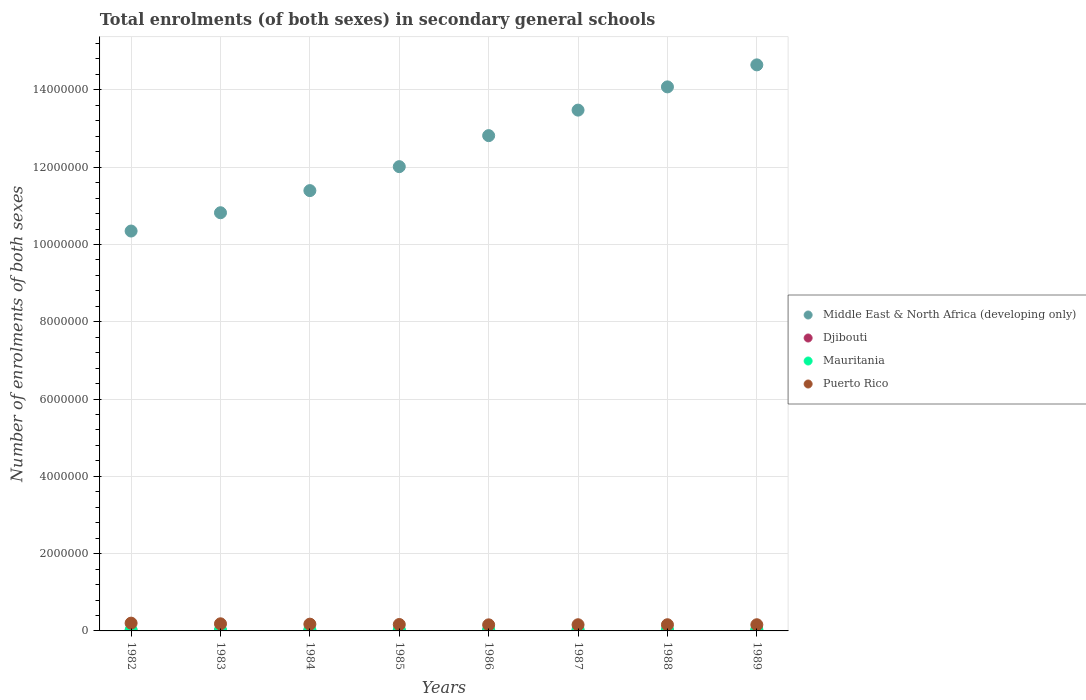What is the number of enrolments in secondary schools in Middle East & North Africa (developing only) in 1988?
Ensure brevity in your answer.  1.41e+07. Across all years, what is the maximum number of enrolments in secondary schools in Puerto Rico?
Ensure brevity in your answer.  2.01e+05. Across all years, what is the minimum number of enrolments in secondary schools in Djibouti?
Your response must be concise. 4076. In which year was the number of enrolments in secondary schools in Middle East & North Africa (developing only) minimum?
Offer a very short reply. 1982. What is the total number of enrolments in secondary schools in Middle East & North Africa (developing only) in the graph?
Offer a very short reply. 9.96e+07. What is the difference between the number of enrolments in secondary schools in Middle East & North Africa (developing only) in 1983 and that in 1984?
Provide a succinct answer. -5.73e+05. What is the difference between the number of enrolments in secondary schools in Puerto Rico in 1983 and the number of enrolments in secondary schools in Middle East & North Africa (developing only) in 1986?
Give a very brief answer. -1.26e+07. What is the average number of enrolments in secondary schools in Mauritania per year?
Make the answer very short. 3.13e+04. In the year 1983, what is the difference between the number of enrolments in secondary schools in Djibouti and number of enrolments in secondary schools in Middle East & North Africa (developing only)?
Your response must be concise. -1.08e+07. What is the ratio of the number of enrolments in secondary schools in Middle East & North Africa (developing only) in 1985 to that in 1988?
Offer a terse response. 0.85. Is the number of enrolments in secondary schools in Mauritania in 1986 less than that in 1989?
Keep it short and to the point. Yes. What is the difference between the highest and the second highest number of enrolments in secondary schools in Middle East & North Africa (developing only)?
Provide a short and direct response. 5.70e+05. What is the difference between the highest and the lowest number of enrolments in secondary schools in Puerto Rico?
Give a very brief answer. 4.36e+04. In how many years, is the number of enrolments in secondary schools in Djibouti greater than the average number of enrolments in secondary schools in Djibouti taken over all years?
Keep it short and to the point. 3. Is it the case that in every year, the sum of the number of enrolments in secondary schools in Puerto Rico and number of enrolments in secondary schools in Middle East & North Africa (developing only)  is greater than the sum of number of enrolments in secondary schools in Djibouti and number of enrolments in secondary schools in Mauritania?
Your response must be concise. No. Is it the case that in every year, the sum of the number of enrolments in secondary schools in Puerto Rico and number of enrolments in secondary schools in Mauritania  is greater than the number of enrolments in secondary schools in Middle East & North Africa (developing only)?
Provide a short and direct response. No. Does the number of enrolments in secondary schools in Middle East & North Africa (developing only) monotonically increase over the years?
Offer a terse response. Yes. Is the number of enrolments in secondary schools in Mauritania strictly less than the number of enrolments in secondary schools in Middle East & North Africa (developing only) over the years?
Provide a succinct answer. Yes. How many dotlines are there?
Your response must be concise. 4. How many years are there in the graph?
Make the answer very short. 8. Are the values on the major ticks of Y-axis written in scientific E-notation?
Offer a very short reply. No. Where does the legend appear in the graph?
Keep it short and to the point. Center right. How many legend labels are there?
Your answer should be very brief. 4. How are the legend labels stacked?
Offer a very short reply. Vertical. What is the title of the graph?
Give a very brief answer. Total enrolments (of both sexes) in secondary general schools. What is the label or title of the X-axis?
Make the answer very short. Years. What is the label or title of the Y-axis?
Your answer should be compact. Number of enrolments of both sexes. What is the Number of enrolments of both sexes in Middle East & North Africa (developing only) in 1982?
Your answer should be very brief. 1.03e+07. What is the Number of enrolments of both sexes in Djibouti in 1982?
Ensure brevity in your answer.  4076. What is the Number of enrolments of both sexes in Mauritania in 1982?
Provide a succinct answer. 2.28e+04. What is the Number of enrolments of both sexes in Puerto Rico in 1982?
Your response must be concise. 2.01e+05. What is the Number of enrolments of both sexes in Middle East & North Africa (developing only) in 1983?
Your answer should be very brief. 1.08e+07. What is the Number of enrolments of both sexes of Djibouti in 1983?
Ensure brevity in your answer.  4429. What is the Number of enrolments of both sexes of Mauritania in 1983?
Make the answer very short. 2.57e+04. What is the Number of enrolments of both sexes in Puerto Rico in 1983?
Give a very brief answer. 1.84e+05. What is the Number of enrolments of both sexes in Middle East & North Africa (developing only) in 1984?
Ensure brevity in your answer.  1.14e+07. What is the Number of enrolments of both sexes of Djibouti in 1984?
Make the answer very short. 4791. What is the Number of enrolments of both sexes of Mauritania in 1984?
Give a very brief answer. 2.79e+04. What is the Number of enrolments of both sexes in Puerto Rico in 1984?
Provide a short and direct response. 1.75e+05. What is the Number of enrolments of both sexes of Middle East & North Africa (developing only) in 1985?
Ensure brevity in your answer.  1.20e+07. What is the Number of enrolments of both sexes in Djibouti in 1985?
Your response must be concise. 4978. What is the Number of enrolments of both sexes of Mauritania in 1985?
Give a very brief answer. 3.08e+04. What is the Number of enrolments of both sexes of Puerto Rico in 1985?
Ensure brevity in your answer.  1.66e+05. What is the Number of enrolments of both sexes in Middle East & North Africa (developing only) in 1986?
Provide a short and direct response. 1.28e+07. What is the Number of enrolments of both sexes of Djibouti in 1986?
Keep it short and to the point. 5057. What is the Number of enrolments of both sexes of Mauritania in 1986?
Your response must be concise. 3.31e+04. What is the Number of enrolments of both sexes in Puerto Rico in 1986?
Keep it short and to the point. 1.57e+05. What is the Number of enrolments of both sexes of Middle East & North Africa (developing only) in 1987?
Offer a very short reply. 1.35e+07. What is the Number of enrolments of both sexes of Djibouti in 1987?
Your response must be concise. 5537. What is the Number of enrolments of both sexes in Mauritania in 1987?
Your answer should be compact. 3.51e+04. What is the Number of enrolments of both sexes of Middle East & North Africa (developing only) in 1988?
Give a very brief answer. 1.41e+07. What is the Number of enrolments of both sexes in Djibouti in 1988?
Offer a very short reply. 5799. What is the Number of enrolments of both sexes of Mauritania in 1988?
Your answer should be very brief. 3.74e+04. What is the Number of enrolments of both sexes of Puerto Rico in 1988?
Keep it short and to the point. 1.60e+05. What is the Number of enrolments of both sexes of Middle East & North Africa (developing only) in 1989?
Offer a terse response. 1.46e+07. What is the Number of enrolments of both sexes of Djibouti in 1989?
Make the answer very short. 6536. What is the Number of enrolments of both sexes of Mauritania in 1989?
Make the answer very short. 3.74e+04. What is the Number of enrolments of both sexes of Puerto Rico in 1989?
Provide a succinct answer. 1.60e+05. Across all years, what is the maximum Number of enrolments of both sexes of Middle East & North Africa (developing only)?
Your answer should be very brief. 1.46e+07. Across all years, what is the maximum Number of enrolments of both sexes of Djibouti?
Offer a terse response. 6536. Across all years, what is the maximum Number of enrolments of both sexes in Mauritania?
Ensure brevity in your answer.  3.74e+04. Across all years, what is the maximum Number of enrolments of both sexes of Puerto Rico?
Provide a succinct answer. 2.01e+05. Across all years, what is the minimum Number of enrolments of both sexes of Middle East & North Africa (developing only)?
Give a very brief answer. 1.03e+07. Across all years, what is the minimum Number of enrolments of both sexes of Djibouti?
Ensure brevity in your answer.  4076. Across all years, what is the minimum Number of enrolments of both sexes in Mauritania?
Your response must be concise. 2.28e+04. Across all years, what is the minimum Number of enrolments of both sexes of Puerto Rico?
Your response must be concise. 1.57e+05. What is the total Number of enrolments of both sexes in Middle East & North Africa (developing only) in the graph?
Make the answer very short. 9.96e+07. What is the total Number of enrolments of both sexes in Djibouti in the graph?
Your response must be concise. 4.12e+04. What is the total Number of enrolments of both sexes of Mauritania in the graph?
Make the answer very short. 2.50e+05. What is the total Number of enrolments of both sexes of Puerto Rico in the graph?
Provide a short and direct response. 1.36e+06. What is the difference between the Number of enrolments of both sexes in Middle East & North Africa (developing only) in 1982 and that in 1983?
Your answer should be very brief. -4.73e+05. What is the difference between the Number of enrolments of both sexes of Djibouti in 1982 and that in 1983?
Ensure brevity in your answer.  -353. What is the difference between the Number of enrolments of both sexes in Mauritania in 1982 and that in 1983?
Ensure brevity in your answer.  -2866. What is the difference between the Number of enrolments of both sexes of Puerto Rico in 1982 and that in 1983?
Give a very brief answer. 1.69e+04. What is the difference between the Number of enrolments of both sexes of Middle East & North Africa (developing only) in 1982 and that in 1984?
Ensure brevity in your answer.  -1.05e+06. What is the difference between the Number of enrolments of both sexes in Djibouti in 1982 and that in 1984?
Offer a terse response. -715. What is the difference between the Number of enrolments of both sexes of Mauritania in 1982 and that in 1984?
Your answer should be very brief. -5090. What is the difference between the Number of enrolments of both sexes in Puerto Rico in 1982 and that in 1984?
Your response must be concise. 2.59e+04. What is the difference between the Number of enrolments of both sexes of Middle East & North Africa (developing only) in 1982 and that in 1985?
Offer a very short reply. -1.67e+06. What is the difference between the Number of enrolments of both sexes of Djibouti in 1982 and that in 1985?
Offer a very short reply. -902. What is the difference between the Number of enrolments of both sexes in Mauritania in 1982 and that in 1985?
Ensure brevity in your answer.  -8006. What is the difference between the Number of enrolments of both sexes of Puerto Rico in 1982 and that in 1985?
Your response must be concise. 3.50e+04. What is the difference between the Number of enrolments of both sexes in Middle East & North Africa (developing only) in 1982 and that in 1986?
Keep it short and to the point. -2.47e+06. What is the difference between the Number of enrolments of both sexes in Djibouti in 1982 and that in 1986?
Your answer should be very brief. -981. What is the difference between the Number of enrolments of both sexes in Mauritania in 1982 and that in 1986?
Your answer should be very brief. -1.03e+04. What is the difference between the Number of enrolments of both sexes of Puerto Rico in 1982 and that in 1986?
Your answer should be very brief. 4.36e+04. What is the difference between the Number of enrolments of both sexes in Middle East & North Africa (developing only) in 1982 and that in 1987?
Provide a short and direct response. -3.13e+06. What is the difference between the Number of enrolments of both sexes of Djibouti in 1982 and that in 1987?
Your answer should be compact. -1461. What is the difference between the Number of enrolments of both sexes in Mauritania in 1982 and that in 1987?
Provide a short and direct response. -1.23e+04. What is the difference between the Number of enrolments of both sexes in Puerto Rico in 1982 and that in 1987?
Offer a terse response. 4.10e+04. What is the difference between the Number of enrolments of both sexes of Middle East & North Africa (developing only) in 1982 and that in 1988?
Keep it short and to the point. -3.73e+06. What is the difference between the Number of enrolments of both sexes of Djibouti in 1982 and that in 1988?
Keep it short and to the point. -1723. What is the difference between the Number of enrolments of both sexes of Mauritania in 1982 and that in 1988?
Keep it short and to the point. -1.46e+04. What is the difference between the Number of enrolments of both sexes in Puerto Rico in 1982 and that in 1988?
Your answer should be compact. 4.10e+04. What is the difference between the Number of enrolments of both sexes of Middle East & North Africa (developing only) in 1982 and that in 1989?
Provide a succinct answer. -4.30e+06. What is the difference between the Number of enrolments of both sexes of Djibouti in 1982 and that in 1989?
Offer a terse response. -2460. What is the difference between the Number of enrolments of both sexes of Mauritania in 1982 and that in 1989?
Your answer should be compact. -1.45e+04. What is the difference between the Number of enrolments of both sexes of Puerto Rico in 1982 and that in 1989?
Give a very brief answer. 4.10e+04. What is the difference between the Number of enrolments of both sexes in Middle East & North Africa (developing only) in 1983 and that in 1984?
Your answer should be compact. -5.73e+05. What is the difference between the Number of enrolments of both sexes of Djibouti in 1983 and that in 1984?
Give a very brief answer. -362. What is the difference between the Number of enrolments of both sexes of Mauritania in 1983 and that in 1984?
Offer a terse response. -2224. What is the difference between the Number of enrolments of both sexes of Puerto Rico in 1983 and that in 1984?
Provide a succinct answer. 9004. What is the difference between the Number of enrolments of both sexes of Middle East & North Africa (developing only) in 1983 and that in 1985?
Provide a succinct answer. -1.19e+06. What is the difference between the Number of enrolments of both sexes in Djibouti in 1983 and that in 1985?
Your answer should be compact. -549. What is the difference between the Number of enrolments of both sexes of Mauritania in 1983 and that in 1985?
Provide a short and direct response. -5140. What is the difference between the Number of enrolments of both sexes in Puerto Rico in 1983 and that in 1985?
Ensure brevity in your answer.  1.81e+04. What is the difference between the Number of enrolments of both sexes in Middle East & North Africa (developing only) in 1983 and that in 1986?
Provide a succinct answer. -2.00e+06. What is the difference between the Number of enrolments of both sexes of Djibouti in 1983 and that in 1986?
Make the answer very short. -628. What is the difference between the Number of enrolments of both sexes in Mauritania in 1983 and that in 1986?
Your response must be concise. -7448. What is the difference between the Number of enrolments of both sexes of Puerto Rico in 1983 and that in 1986?
Your answer should be very brief. 2.67e+04. What is the difference between the Number of enrolments of both sexes of Middle East & North Africa (developing only) in 1983 and that in 1987?
Make the answer very short. -2.66e+06. What is the difference between the Number of enrolments of both sexes of Djibouti in 1983 and that in 1987?
Provide a short and direct response. -1108. What is the difference between the Number of enrolments of both sexes of Mauritania in 1983 and that in 1987?
Your response must be concise. -9429. What is the difference between the Number of enrolments of both sexes in Puerto Rico in 1983 and that in 1987?
Offer a terse response. 2.41e+04. What is the difference between the Number of enrolments of both sexes in Middle East & North Africa (developing only) in 1983 and that in 1988?
Give a very brief answer. -3.26e+06. What is the difference between the Number of enrolments of both sexes of Djibouti in 1983 and that in 1988?
Your answer should be compact. -1370. What is the difference between the Number of enrolments of both sexes of Mauritania in 1983 and that in 1988?
Your answer should be very brief. -1.17e+04. What is the difference between the Number of enrolments of both sexes of Puerto Rico in 1983 and that in 1988?
Give a very brief answer. 2.41e+04. What is the difference between the Number of enrolments of both sexes in Middle East & North Africa (developing only) in 1983 and that in 1989?
Provide a short and direct response. -3.83e+06. What is the difference between the Number of enrolments of both sexes of Djibouti in 1983 and that in 1989?
Make the answer very short. -2107. What is the difference between the Number of enrolments of both sexes in Mauritania in 1983 and that in 1989?
Provide a short and direct response. -1.17e+04. What is the difference between the Number of enrolments of both sexes in Puerto Rico in 1983 and that in 1989?
Provide a succinct answer. 2.41e+04. What is the difference between the Number of enrolments of both sexes in Middle East & North Africa (developing only) in 1984 and that in 1985?
Provide a short and direct response. -6.20e+05. What is the difference between the Number of enrolments of both sexes of Djibouti in 1984 and that in 1985?
Your answer should be compact. -187. What is the difference between the Number of enrolments of both sexes in Mauritania in 1984 and that in 1985?
Your answer should be compact. -2916. What is the difference between the Number of enrolments of both sexes of Puerto Rico in 1984 and that in 1985?
Offer a terse response. 9100. What is the difference between the Number of enrolments of both sexes in Middle East & North Africa (developing only) in 1984 and that in 1986?
Your answer should be very brief. -1.42e+06. What is the difference between the Number of enrolments of both sexes in Djibouti in 1984 and that in 1986?
Give a very brief answer. -266. What is the difference between the Number of enrolments of both sexes in Mauritania in 1984 and that in 1986?
Give a very brief answer. -5224. What is the difference between the Number of enrolments of both sexes in Puerto Rico in 1984 and that in 1986?
Provide a short and direct response. 1.77e+04. What is the difference between the Number of enrolments of both sexes of Middle East & North Africa (developing only) in 1984 and that in 1987?
Offer a very short reply. -2.08e+06. What is the difference between the Number of enrolments of both sexes of Djibouti in 1984 and that in 1987?
Provide a succinct answer. -746. What is the difference between the Number of enrolments of both sexes in Mauritania in 1984 and that in 1987?
Offer a terse response. -7205. What is the difference between the Number of enrolments of both sexes in Puerto Rico in 1984 and that in 1987?
Your answer should be compact. 1.51e+04. What is the difference between the Number of enrolments of both sexes of Middle East & North Africa (developing only) in 1984 and that in 1988?
Your response must be concise. -2.68e+06. What is the difference between the Number of enrolments of both sexes of Djibouti in 1984 and that in 1988?
Your answer should be very brief. -1008. What is the difference between the Number of enrolments of both sexes in Mauritania in 1984 and that in 1988?
Ensure brevity in your answer.  -9488. What is the difference between the Number of enrolments of both sexes in Puerto Rico in 1984 and that in 1988?
Your response must be concise. 1.51e+04. What is the difference between the Number of enrolments of both sexes in Middle East & North Africa (developing only) in 1984 and that in 1989?
Your answer should be compact. -3.25e+06. What is the difference between the Number of enrolments of both sexes in Djibouti in 1984 and that in 1989?
Make the answer very short. -1745. What is the difference between the Number of enrolments of both sexes in Mauritania in 1984 and that in 1989?
Make the answer very short. -9446. What is the difference between the Number of enrolments of both sexes in Puerto Rico in 1984 and that in 1989?
Offer a very short reply. 1.51e+04. What is the difference between the Number of enrolments of both sexes of Middle East & North Africa (developing only) in 1985 and that in 1986?
Provide a succinct answer. -8.03e+05. What is the difference between the Number of enrolments of both sexes in Djibouti in 1985 and that in 1986?
Your answer should be compact. -79. What is the difference between the Number of enrolments of both sexes in Mauritania in 1985 and that in 1986?
Your answer should be very brief. -2308. What is the difference between the Number of enrolments of both sexes of Puerto Rico in 1985 and that in 1986?
Provide a succinct answer. 8620. What is the difference between the Number of enrolments of both sexes in Middle East & North Africa (developing only) in 1985 and that in 1987?
Provide a short and direct response. -1.46e+06. What is the difference between the Number of enrolments of both sexes of Djibouti in 1985 and that in 1987?
Provide a short and direct response. -559. What is the difference between the Number of enrolments of both sexes of Mauritania in 1985 and that in 1987?
Offer a very short reply. -4289. What is the difference between the Number of enrolments of both sexes of Puerto Rico in 1985 and that in 1987?
Your answer should be compact. 6000. What is the difference between the Number of enrolments of both sexes in Middle East & North Africa (developing only) in 1985 and that in 1988?
Your answer should be compact. -2.06e+06. What is the difference between the Number of enrolments of both sexes of Djibouti in 1985 and that in 1988?
Offer a terse response. -821. What is the difference between the Number of enrolments of both sexes of Mauritania in 1985 and that in 1988?
Give a very brief answer. -6572. What is the difference between the Number of enrolments of both sexes of Puerto Rico in 1985 and that in 1988?
Your answer should be compact. 6000. What is the difference between the Number of enrolments of both sexes of Middle East & North Africa (developing only) in 1985 and that in 1989?
Keep it short and to the point. -2.63e+06. What is the difference between the Number of enrolments of both sexes of Djibouti in 1985 and that in 1989?
Make the answer very short. -1558. What is the difference between the Number of enrolments of both sexes in Mauritania in 1985 and that in 1989?
Offer a very short reply. -6530. What is the difference between the Number of enrolments of both sexes of Puerto Rico in 1985 and that in 1989?
Provide a short and direct response. 6000. What is the difference between the Number of enrolments of both sexes in Middle East & North Africa (developing only) in 1986 and that in 1987?
Provide a succinct answer. -6.60e+05. What is the difference between the Number of enrolments of both sexes of Djibouti in 1986 and that in 1987?
Ensure brevity in your answer.  -480. What is the difference between the Number of enrolments of both sexes in Mauritania in 1986 and that in 1987?
Your answer should be compact. -1981. What is the difference between the Number of enrolments of both sexes in Puerto Rico in 1986 and that in 1987?
Offer a very short reply. -2620. What is the difference between the Number of enrolments of both sexes in Middle East & North Africa (developing only) in 1986 and that in 1988?
Provide a short and direct response. -1.26e+06. What is the difference between the Number of enrolments of both sexes of Djibouti in 1986 and that in 1988?
Offer a terse response. -742. What is the difference between the Number of enrolments of both sexes in Mauritania in 1986 and that in 1988?
Your response must be concise. -4264. What is the difference between the Number of enrolments of both sexes in Puerto Rico in 1986 and that in 1988?
Offer a terse response. -2620. What is the difference between the Number of enrolments of both sexes in Middle East & North Africa (developing only) in 1986 and that in 1989?
Keep it short and to the point. -1.83e+06. What is the difference between the Number of enrolments of both sexes of Djibouti in 1986 and that in 1989?
Offer a terse response. -1479. What is the difference between the Number of enrolments of both sexes in Mauritania in 1986 and that in 1989?
Provide a short and direct response. -4222. What is the difference between the Number of enrolments of both sexes of Puerto Rico in 1986 and that in 1989?
Offer a very short reply. -2620. What is the difference between the Number of enrolments of both sexes of Middle East & North Africa (developing only) in 1987 and that in 1988?
Provide a succinct answer. -6.01e+05. What is the difference between the Number of enrolments of both sexes in Djibouti in 1987 and that in 1988?
Your answer should be compact. -262. What is the difference between the Number of enrolments of both sexes of Mauritania in 1987 and that in 1988?
Provide a short and direct response. -2283. What is the difference between the Number of enrolments of both sexes in Puerto Rico in 1987 and that in 1988?
Make the answer very short. 0. What is the difference between the Number of enrolments of both sexes in Middle East & North Africa (developing only) in 1987 and that in 1989?
Offer a terse response. -1.17e+06. What is the difference between the Number of enrolments of both sexes of Djibouti in 1987 and that in 1989?
Offer a very short reply. -999. What is the difference between the Number of enrolments of both sexes of Mauritania in 1987 and that in 1989?
Your response must be concise. -2241. What is the difference between the Number of enrolments of both sexes of Puerto Rico in 1987 and that in 1989?
Offer a terse response. 0. What is the difference between the Number of enrolments of both sexes in Middle East & North Africa (developing only) in 1988 and that in 1989?
Your answer should be compact. -5.70e+05. What is the difference between the Number of enrolments of both sexes in Djibouti in 1988 and that in 1989?
Your answer should be very brief. -737. What is the difference between the Number of enrolments of both sexes in Puerto Rico in 1988 and that in 1989?
Your response must be concise. 0. What is the difference between the Number of enrolments of both sexes of Middle East & North Africa (developing only) in 1982 and the Number of enrolments of both sexes of Djibouti in 1983?
Make the answer very short. 1.03e+07. What is the difference between the Number of enrolments of both sexes of Middle East & North Africa (developing only) in 1982 and the Number of enrolments of both sexes of Mauritania in 1983?
Ensure brevity in your answer.  1.03e+07. What is the difference between the Number of enrolments of both sexes in Middle East & North Africa (developing only) in 1982 and the Number of enrolments of both sexes in Puerto Rico in 1983?
Your answer should be very brief. 1.02e+07. What is the difference between the Number of enrolments of both sexes in Djibouti in 1982 and the Number of enrolments of both sexes in Mauritania in 1983?
Offer a very short reply. -2.16e+04. What is the difference between the Number of enrolments of both sexes of Djibouti in 1982 and the Number of enrolments of both sexes of Puerto Rico in 1983?
Keep it short and to the point. -1.80e+05. What is the difference between the Number of enrolments of both sexes of Mauritania in 1982 and the Number of enrolments of both sexes of Puerto Rico in 1983?
Offer a terse response. -1.61e+05. What is the difference between the Number of enrolments of both sexes in Middle East & North Africa (developing only) in 1982 and the Number of enrolments of both sexes in Djibouti in 1984?
Provide a succinct answer. 1.03e+07. What is the difference between the Number of enrolments of both sexes of Middle East & North Africa (developing only) in 1982 and the Number of enrolments of both sexes of Mauritania in 1984?
Give a very brief answer. 1.03e+07. What is the difference between the Number of enrolments of both sexes in Middle East & North Africa (developing only) in 1982 and the Number of enrolments of both sexes in Puerto Rico in 1984?
Your answer should be compact. 1.02e+07. What is the difference between the Number of enrolments of both sexes in Djibouti in 1982 and the Number of enrolments of both sexes in Mauritania in 1984?
Ensure brevity in your answer.  -2.38e+04. What is the difference between the Number of enrolments of both sexes of Djibouti in 1982 and the Number of enrolments of both sexes of Puerto Rico in 1984?
Make the answer very short. -1.71e+05. What is the difference between the Number of enrolments of both sexes of Mauritania in 1982 and the Number of enrolments of both sexes of Puerto Rico in 1984?
Your answer should be compact. -1.52e+05. What is the difference between the Number of enrolments of both sexes of Middle East & North Africa (developing only) in 1982 and the Number of enrolments of both sexes of Djibouti in 1985?
Offer a very short reply. 1.03e+07. What is the difference between the Number of enrolments of both sexes in Middle East & North Africa (developing only) in 1982 and the Number of enrolments of both sexes in Mauritania in 1985?
Your answer should be compact. 1.03e+07. What is the difference between the Number of enrolments of both sexes of Middle East & North Africa (developing only) in 1982 and the Number of enrolments of both sexes of Puerto Rico in 1985?
Offer a terse response. 1.02e+07. What is the difference between the Number of enrolments of both sexes in Djibouti in 1982 and the Number of enrolments of both sexes in Mauritania in 1985?
Provide a succinct answer. -2.68e+04. What is the difference between the Number of enrolments of both sexes of Djibouti in 1982 and the Number of enrolments of both sexes of Puerto Rico in 1985?
Ensure brevity in your answer.  -1.62e+05. What is the difference between the Number of enrolments of both sexes of Mauritania in 1982 and the Number of enrolments of both sexes of Puerto Rico in 1985?
Offer a very short reply. -1.43e+05. What is the difference between the Number of enrolments of both sexes of Middle East & North Africa (developing only) in 1982 and the Number of enrolments of both sexes of Djibouti in 1986?
Ensure brevity in your answer.  1.03e+07. What is the difference between the Number of enrolments of both sexes of Middle East & North Africa (developing only) in 1982 and the Number of enrolments of both sexes of Mauritania in 1986?
Your answer should be compact. 1.03e+07. What is the difference between the Number of enrolments of both sexes of Middle East & North Africa (developing only) in 1982 and the Number of enrolments of both sexes of Puerto Rico in 1986?
Ensure brevity in your answer.  1.02e+07. What is the difference between the Number of enrolments of both sexes of Djibouti in 1982 and the Number of enrolments of both sexes of Mauritania in 1986?
Provide a short and direct response. -2.91e+04. What is the difference between the Number of enrolments of both sexes in Djibouti in 1982 and the Number of enrolments of both sexes in Puerto Rico in 1986?
Make the answer very short. -1.53e+05. What is the difference between the Number of enrolments of both sexes in Mauritania in 1982 and the Number of enrolments of both sexes in Puerto Rico in 1986?
Provide a short and direct response. -1.35e+05. What is the difference between the Number of enrolments of both sexes of Middle East & North Africa (developing only) in 1982 and the Number of enrolments of both sexes of Djibouti in 1987?
Your response must be concise. 1.03e+07. What is the difference between the Number of enrolments of both sexes of Middle East & North Africa (developing only) in 1982 and the Number of enrolments of both sexes of Mauritania in 1987?
Offer a very short reply. 1.03e+07. What is the difference between the Number of enrolments of both sexes of Middle East & North Africa (developing only) in 1982 and the Number of enrolments of both sexes of Puerto Rico in 1987?
Your answer should be very brief. 1.02e+07. What is the difference between the Number of enrolments of both sexes of Djibouti in 1982 and the Number of enrolments of both sexes of Mauritania in 1987?
Keep it short and to the point. -3.11e+04. What is the difference between the Number of enrolments of both sexes in Djibouti in 1982 and the Number of enrolments of both sexes in Puerto Rico in 1987?
Provide a short and direct response. -1.56e+05. What is the difference between the Number of enrolments of both sexes of Mauritania in 1982 and the Number of enrolments of both sexes of Puerto Rico in 1987?
Provide a succinct answer. -1.37e+05. What is the difference between the Number of enrolments of both sexes of Middle East & North Africa (developing only) in 1982 and the Number of enrolments of both sexes of Djibouti in 1988?
Your response must be concise. 1.03e+07. What is the difference between the Number of enrolments of both sexes of Middle East & North Africa (developing only) in 1982 and the Number of enrolments of both sexes of Mauritania in 1988?
Your answer should be compact. 1.03e+07. What is the difference between the Number of enrolments of both sexes in Middle East & North Africa (developing only) in 1982 and the Number of enrolments of both sexes in Puerto Rico in 1988?
Your answer should be very brief. 1.02e+07. What is the difference between the Number of enrolments of both sexes in Djibouti in 1982 and the Number of enrolments of both sexes in Mauritania in 1988?
Ensure brevity in your answer.  -3.33e+04. What is the difference between the Number of enrolments of both sexes in Djibouti in 1982 and the Number of enrolments of both sexes in Puerto Rico in 1988?
Your response must be concise. -1.56e+05. What is the difference between the Number of enrolments of both sexes in Mauritania in 1982 and the Number of enrolments of both sexes in Puerto Rico in 1988?
Give a very brief answer. -1.37e+05. What is the difference between the Number of enrolments of both sexes of Middle East & North Africa (developing only) in 1982 and the Number of enrolments of both sexes of Djibouti in 1989?
Your answer should be very brief. 1.03e+07. What is the difference between the Number of enrolments of both sexes in Middle East & North Africa (developing only) in 1982 and the Number of enrolments of both sexes in Mauritania in 1989?
Your answer should be compact. 1.03e+07. What is the difference between the Number of enrolments of both sexes in Middle East & North Africa (developing only) in 1982 and the Number of enrolments of both sexes in Puerto Rico in 1989?
Your answer should be compact. 1.02e+07. What is the difference between the Number of enrolments of both sexes of Djibouti in 1982 and the Number of enrolments of both sexes of Mauritania in 1989?
Provide a succinct answer. -3.33e+04. What is the difference between the Number of enrolments of both sexes of Djibouti in 1982 and the Number of enrolments of both sexes of Puerto Rico in 1989?
Your answer should be very brief. -1.56e+05. What is the difference between the Number of enrolments of both sexes of Mauritania in 1982 and the Number of enrolments of both sexes of Puerto Rico in 1989?
Your answer should be very brief. -1.37e+05. What is the difference between the Number of enrolments of both sexes of Middle East & North Africa (developing only) in 1983 and the Number of enrolments of both sexes of Djibouti in 1984?
Ensure brevity in your answer.  1.08e+07. What is the difference between the Number of enrolments of both sexes in Middle East & North Africa (developing only) in 1983 and the Number of enrolments of both sexes in Mauritania in 1984?
Your answer should be compact. 1.08e+07. What is the difference between the Number of enrolments of both sexes in Middle East & North Africa (developing only) in 1983 and the Number of enrolments of both sexes in Puerto Rico in 1984?
Keep it short and to the point. 1.06e+07. What is the difference between the Number of enrolments of both sexes of Djibouti in 1983 and the Number of enrolments of both sexes of Mauritania in 1984?
Keep it short and to the point. -2.35e+04. What is the difference between the Number of enrolments of both sexes of Djibouti in 1983 and the Number of enrolments of both sexes of Puerto Rico in 1984?
Ensure brevity in your answer.  -1.71e+05. What is the difference between the Number of enrolments of both sexes in Mauritania in 1983 and the Number of enrolments of both sexes in Puerto Rico in 1984?
Provide a succinct answer. -1.49e+05. What is the difference between the Number of enrolments of both sexes in Middle East & North Africa (developing only) in 1983 and the Number of enrolments of both sexes in Djibouti in 1985?
Your answer should be very brief. 1.08e+07. What is the difference between the Number of enrolments of both sexes in Middle East & North Africa (developing only) in 1983 and the Number of enrolments of both sexes in Mauritania in 1985?
Offer a terse response. 1.08e+07. What is the difference between the Number of enrolments of both sexes of Middle East & North Africa (developing only) in 1983 and the Number of enrolments of both sexes of Puerto Rico in 1985?
Provide a succinct answer. 1.07e+07. What is the difference between the Number of enrolments of both sexes in Djibouti in 1983 and the Number of enrolments of both sexes in Mauritania in 1985?
Your response must be concise. -2.64e+04. What is the difference between the Number of enrolments of both sexes of Djibouti in 1983 and the Number of enrolments of both sexes of Puerto Rico in 1985?
Your response must be concise. -1.62e+05. What is the difference between the Number of enrolments of both sexes of Mauritania in 1983 and the Number of enrolments of both sexes of Puerto Rico in 1985?
Your response must be concise. -1.40e+05. What is the difference between the Number of enrolments of both sexes of Middle East & North Africa (developing only) in 1983 and the Number of enrolments of both sexes of Djibouti in 1986?
Ensure brevity in your answer.  1.08e+07. What is the difference between the Number of enrolments of both sexes of Middle East & North Africa (developing only) in 1983 and the Number of enrolments of both sexes of Mauritania in 1986?
Your answer should be compact. 1.08e+07. What is the difference between the Number of enrolments of both sexes of Middle East & North Africa (developing only) in 1983 and the Number of enrolments of both sexes of Puerto Rico in 1986?
Provide a short and direct response. 1.07e+07. What is the difference between the Number of enrolments of both sexes in Djibouti in 1983 and the Number of enrolments of both sexes in Mauritania in 1986?
Provide a short and direct response. -2.87e+04. What is the difference between the Number of enrolments of both sexes of Djibouti in 1983 and the Number of enrolments of both sexes of Puerto Rico in 1986?
Offer a terse response. -1.53e+05. What is the difference between the Number of enrolments of both sexes in Mauritania in 1983 and the Number of enrolments of both sexes in Puerto Rico in 1986?
Provide a short and direct response. -1.32e+05. What is the difference between the Number of enrolments of both sexes in Middle East & North Africa (developing only) in 1983 and the Number of enrolments of both sexes in Djibouti in 1987?
Your response must be concise. 1.08e+07. What is the difference between the Number of enrolments of both sexes in Middle East & North Africa (developing only) in 1983 and the Number of enrolments of both sexes in Mauritania in 1987?
Provide a short and direct response. 1.08e+07. What is the difference between the Number of enrolments of both sexes of Middle East & North Africa (developing only) in 1983 and the Number of enrolments of both sexes of Puerto Rico in 1987?
Your answer should be very brief. 1.07e+07. What is the difference between the Number of enrolments of both sexes of Djibouti in 1983 and the Number of enrolments of both sexes of Mauritania in 1987?
Keep it short and to the point. -3.07e+04. What is the difference between the Number of enrolments of both sexes in Djibouti in 1983 and the Number of enrolments of both sexes in Puerto Rico in 1987?
Your response must be concise. -1.56e+05. What is the difference between the Number of enrolments of both sexes of Mauritania in 1983 and the Number of enrolments of both sexes of Puerto Rico in 1987?
Your response must be concise. -1.34e+05. What is the difference between the Number of enrolments of both sexes of Middle East & North Africa (developing only) in 1983 and the Number of enrolments of both sexes of Djibouti in 1988?
Offer a very short reply. 1.08e+07. What is the difference between the Number of enrolments of both sexes in Middle East & North Africa (developing only) in 1983 and the Number of enrolments of both sexes in Mauritania in 1988?
Offer a terse response. 1.08e+07. What is the difference between the Number of enrolments of both sexes of Middle East & North Africa (developing only) in 1983 and the Number of enrolments of both sexes of Puerto Rico in 1988?
Offer a very short reply. 1.07e+07. What is the difference between the Number of enrolments of both sexes in Djibouti in 1983 and the Number of enrolments of both sexes in Mauritania in 1988?
Offer a terse response. -3.30e+04. What is the difference between the Number of enrolments of both sexes in Djibouti in 1983 and the Number of enrolments of both sexes in Puerto Rico in 1988?
Provide a succinct answer. -1.56e+05. What is the difference between the Number of enrolments of both sexes in Mauritania in 1983 and the Number of enrolments of both sexes in Puerto Rico in 1988?
Offer a very short reply. -1.34e+05. What is the difference between the Number of enrolments of both sexes of Middle East & North Africa (developing only) in 1983 and the Number of enrolments of both sexes of Djibouti in 1989?
Offer a very short reply. 1.08e+07. What is the difference between the Number of enrolments of both sexes of Middle East & North Africa (developing only) in 1983 and the Number of enrolments of both sexes of Mauritania in 1989?
Your response must be concise. 1.08e+07. What is the difference between the Number of enrolments of both sexes of Middle East & North Africa (developing only) in 1983 and the Number of enrolments of both sexes of Puerto Rico in 1989?
Ensure brevity in your answer.  1.07e+07. What is the difference between the Number of enrolments of both sexes in Djibouti in 1983 and the Number of enrolments of both sexes in Mauritania in 1989?
Ensure brevity in your answer.  -3.29e+04. What is the difference between the Number of enrolments of both sexes of Djibouti in 1983 and the Number of enrolments of both sexes of Puerto Rico in 1989?
Make the answer very short. -1.56e+05. What is the difference between the Number of enrolments of both sexes of Mauritania in 1983 and the Number of enrolments of both sexes of Puerto Rico in 1989?
Make the answer very short. -1.34e+05. What is the difference between the Number of enrolments of both sexes of Middle East & North Africa (developing only) in 1984 and the Number of enrolments of both sexes of Djibouti in 1985?
Ensure brevity in your answer.  1.14e+07. What is the difference between the Number of enrolments of both sexes in Middle East & North Africa (developing only) in 1984 and the Number of enrolments of both sexes in Mauritania in 1985?
Your answer should be very brief. 1.14e+07. What is the difference between the Number of enrolments of both sexes of Middle East & North Africa (developing only) in 1984 and the Number of enrolments of both sexes of Puerto Rico in 1985?
Ensure brevity in your answer.  1.12e+07. What is the difference between the Number of enrolments of both sexes of Djibouti in 1984 and the Number of enrolments of both sexes of Mauritania in 1985?
Ensure brevity in your answer.  -2.60e+04. What is the difference between the Number of enrolments of both sexes of Djibouti in 1984 and the Number of enrolments of both sexes of Puerto Rico in 1985?
Offer a very short reply. -1.61e+05. What is the difference between the Number of enrolments of both sexes of Mauritania in 1984 and the Number of enrolments of both sexes of Puerto Rico in 1985?
Your response must be concise. -1.38e+05. What is the difference between the Number of enrolments of both sexes in Middle East & North Africa (developing only) in 1984 and the Number of enrolments of both sexes in Djibouti in 1986?
Your answer should be compact. 1.14e+07. What is the difference between the Number of enrolments of both sexes in Middle East & North Africa (developing only) in 1984 and the Number of enrolments of both sexes in Mauritania in 1986?
Offer a very short reply. 1.14e+07. What is the difference between the Number of enrolments of both sexes in Middle East & North Africa (developing only) in 1984 and the Number of enrolments of both sexes in Puerto Rico in 1986?
Ensure brevity in your answer.  1.12e+07. What is the difference between the Number of enrolments of both sexes of Djibouti in 1984 and the Number of enrolments of both sexes of Mauritania in 1986?
Your answer should be compact. -2.84e+04. What is the difference between the Number of enrolments of both sexes in Djibouti in 1984 and the Number of enrolments of both sexes in Puerto Rico in 1986?
Offer a very short reply. -1.53e+05. What is the difference between the Number of enrolments of both sexes of Mauritania in 1984 and the Number of enrolments of both sexes of Puerto Rico in 1986?
Your response must be concise. -1.29e+05. What is the difference between the Number of enrolments of both sexes in Middle East & North Africa (developing only) in 1984 and the Number of enrolments of both sexes in Djibouti in 1987?
Offer a very short reply. 1.14e+07. What is the difference between the Number of enrolments of both sexes of Middle East & North Africa (developing only) in 1984 and the Number of enrolments of both sexes of Mauritania in 1987?
Keep it short and to the point. 1.14e+07. What is the difference between the Number of enrolments of both sexes of Middle East & North Africa (developing only) in 1984 and the Number of enrolments of both sexes of Puerto Rico in 1987?
Your response must be concise. 1.12e+07. What is the difference between the Number of enrolments of both sexes in Djibouti in 1984 and the Number of enrolments of both sexes in Mauritania in 1987?
Provide a short and direct response. -3.03e+04. What is the difference between the Number of enrolments of both sexes of Djibouti in 1984 and the Number of enrolments of both sexes of Puerto Rico in 1987?
Keep it short and to the point. -1.55e+05. What is the difference between the Number of enrolments of both sexes in Mauritania in 1984 and the Number of enrolments of both sexes in Puerto Rico in 1987?
Give a very brief answer. -1.32e+05. What is the difference between the Number of enrolments of both sexes of Middle East & North Africa (developing only) in 1984 and the Number of enrolments of both sexes of Djibouti in 1988?
Your answer should be very brief. 1.14e+07. What is the difference between the Number of enrolments of both sexes of Middle East & North Africa (developing only) in 1984 and the Number of enrolments of both sexes of Mauritania in 1988?
Your answer should be compact. 1.14e+07. What is the difference between the Number of enrolments of both sexes in Middle East & North Africa (developing only) in 1984 and the Number of enrolments of both sexes in Puerto Rico in 1988?
Provide a short and direct response. 1.12e+07. What is the difference between the Number of enrolments of both sexes in Djibouti in 1984 and the Number of enrolments of both sexes in Mauritania in 1988?
Make the answer very short. -3.26e+04. What is the difference between the Number of enrolments of both sexes in Djibouti in 1984 and the Number of enrolments of both sexes in Puerto Rico in 1988?
Provide a short and direct response. -1.55e+05. What is the difference between the Number of enrolments of both sexes in Mauritania in 1984 and the Number of enrolments of both sexes in Puerto Rico in 1988?
Provide a succinct answer. -1.32e+05. What is the difference between the Number of enrolments of both sexes of Middle East & North Africa (developing only) in 1984 and the Number of enrolments of both sexes of Djibouti in 1989?
Give a very brief answer. 1.14e+07. What is the difference between the Number of enrolments of both sexes of Middle East & North Africa (developing only) in 1984 and the Number of enrolments of both sexes of Mauritania in 1989?
Provide a short and direct response. 1.14e+07. What is the difference between the Number of enrolments of both sexes in Middle East & North Africa (developing only) in 1984 and the Number of enrolments of both sexes in Puerto Rico in 1989?
Ensure brevity in your answer.  1.12e+07. What is the difference between the Number of enrolments of both sexes of Djibouti in 1984 and the Number of enrolments of both sexes of Mauritania in 1989?
Give a very brief answer. -3.26e+04. What is the difference between the Number of enrolments of both sexes of Djibouti in 1984 and the Number of enrolments of both sexes of Puerto Rico in 1989?
Your response must be concise. -1.55e+05. What is the difference between the Number of enrolments of both sexes in Mauritania in 1984 and the Number of enrolments of both sexes in Puerto Rico in 1989?
Offer a terse response. -1.32e+05. What is the difference between the Number of enrolments of both sexes in Middle East & North Africa (developing only) in 1985 and the Number of enrolments of both sexes in Djibouti in 1986?
Your answer should be compact. 1.20e+07. What is the difference between the Number of enrolments of both sexes in Middle East & North Africa (developing only) in 1985 and the Number of enrolments of both sexes in Mauritania in 1986?
Offer a very short reply. 1.20e+07. What is the difference between the Number of enrolments of both sexes in Middle East & North Africa (developing only) in 1985 and the Number of enrolments of both sexes in Puerto Rico in 1986?
Offer a very short reply. 1.19e+07. What is the difference between the Number of enrolments of both sexes in Djibouti in 1985 and the Number of enrolments of both sexes in Mauritania in 1986?
Give a very brief answer. -2.82e+04. What is the difference between the Number of enrolments of both sexes in Djibouti in 1985 and the Number of enrolments of both sexes in Puerto Rico in 1986?
Your response must be concise. -1.52e+05. What is the difference between the Number of enrolments of both sexes of Mauritania in 1985 and the Number of enrolments of both sexes of Puerto Rico in 1986?
Make the answer very short. -1.27e+05. What is the difference between the Number of enrolments of both sexes of Middle East & North Africa (developing only) in 1985 and the Number of enrolments of both sexes of Djibouti in 1987?
Your answer should be very brief. 1.20e+07. What is the difference between the Number of enrolments of both sexes of Middle East & North Africa (developing only) in 1985 and the Number of enrolments of both sexes of Mauritania in 1987?
Provide a succinct answer. 1.20e+07. What is the difference between the Number of enrolments of both sexes of Middle East & North Africa (developing only) in 1985 and the Number of enrolments of both sexes of Puerto Rico in 1987?
Offer a terse response. 1.19e+07. What is the difference between the Number of enrolments of both sexes of Djibouti in 1985 and the Number of enrolments of both sexes of Mauritania in 1987?
Offer a terse response. -3.02e+04. What is the difference between the Number of enrolments of both sexes in Djibouti in 1985 and the Number of enrolments of both sexes in Puerto Rico in 1987?
Your answer should be compact. -1.55e+05. What is the difference between the Number of enrolments of both sexes in Mauritania in 1985 and the Number of enrolments of both sexes in Puerto Rico in 1987?
Ensure brevity in your answer.  -1.29e+05. What is the difference between the Number of enrolments of both sexes of Middle East & North Africa (developing only) in 1985 and the Number of enrolments of both sexes of Djibouti in 1988?
Provide a short and direct response. 1.20e+07. What is the difference between the Number of enrolments of both sexes of Middle East & North Africa (developing only) in 1985 and the Number of enrolments of both sexes of Mauritania in 1988?
Offer a very short reply. 1.20e+07. What is the difference between the Number of enrolments of both sexes in Middle East & North Africa (developing only) in 1985 and the Number of enrolments of both sexes in Puerto Rico in 1988?
Provide a succinct answer. 1.19e+07. What is the difference between the Number of enrolments of both sexes in Djibouti in 1985 and the Number of enrolments of both sexes in Mauritania in 1988?
Provide a succinct answer. -3.24e+04. What is the difference between the Number of enrolments of both sexes in Djibouti in 1985 and the Number of enrolments of both sexes in Puerto Rico in 1988?
Offer a terse response. -1.55e+05. What is the difference between the Number of enrolments of both sexes of Mauritania in 1985 and the Number of enrolments of both sexes of Puerto Rico in 1988?
Ensure brevity in your answer.  -1.29e+05. What is the difference between the Number of enrolments of both sexes in Middle East & North Africa (developing only) in 1985 and the Number of enrolments of both sexes in Djibouti in 1989?
Offer a terse response. 1.20e+07. What is the difference between the Number of enrolments of both sexes in Middle East & North Africa (developing only) in 1985 and the Number of enrolments of both sexes in Mauritania in 1989?
Your response must be concise. 1.20e+07. What is the difference between the Number of enrolments of both sexes in Middle East & North Africa (developing only) in 1985 and the Number of enrolments of both sexes in Puerto Rico in 1989?
Offer a terse response. 1.19e+07. What is the difference between the Number of enrolments of both sexes in Djibouti in 1985 and the Number of enrolments of both sexes in Mauritania in 1989?
Your response must be concise. -3.24e+04. What is the difference between the Number of enrolments of both sexes in Djibouti in 1985 and the Number of enrolments of both sexes in Puerto Rico in 1989?
Your answer should be very brief. -1.55e+05. What is the difference between the Number of enrolments of both sexes of Mauritania in 1985 and the Number of enrolments of both sexes of Puerto Rico in 1989?
Make the answer very short. -1.29e+05. What is the difference between the Number of enrolments of both sexes in Middle East & North Africa (developing only) in 1986 and the Number of enrolments of both sexes in Djibouti in 1987?
Provide a short and direct response. 1.28e+07. What is the difference between the Number of enrolments of both sexes in Middle East & North Africa (developing only) in 1986 and the Number of enrolments of both sexes in Mauritania in 1987?
Your response must be concise. 1.28e+07. What is the difference between the Number of enrolments of both sexes in Middle East & North Africa (developing only) in 1986 and the Number of enrolments of both sexes in Puerto Rico in 1987?
Offer a terse response. 1.27e+07. What is the difference between the Number of enrolments of both sexes of Djibouti in 1986 and the Number of enrolments of both sexes of Mauritania in 1987?
Ensure brevity in your answer.  -3.01e+04. What is the difference between the Number of enrolments of both sexes of Djibouti in 1986 and the Number of enrolments of both sexes of Puerto Rico in 1987?
Make the answer very short. -1.55e+05. What is the difference between the Number of enrolments of both sexes of Mauritania in 1986 and the Number of enrolments of both sexes of Puerto Rico in 1987?
Make the answer very short. -1.27e+05. What is the difference between the Number of enrolments of both sexes in Middle East & North Africa (developing only) in 1986 and the Number of enrolments of both sexes in Djibouti in 1988?
Give a very brief answer. 1.28e+07. What is the difference between the Number of enrolments of both sexes of Middle East & North Africa (developing only) in 1986 and the Number of enrolments of both sexes of Mauritania in 1988?
Your answer should be very brief. 1.28e+07. What is the difference between the Number of enrolments of both sexes in Middle East & North Africa (developing only) in 1986 and the Number of enrolments of both sexes in Puerto Rico in 1988?
Offer a terse response. 1.27e+07. What is the difference between the Number of enrolments of both sexes in Djibouti in 1986 and the Number of enrolments of both sexes in Mauritania in 1988?
Make the answer very short. -3.24e+04. What is the difference between the Number of enrolments of both sexes in Djibouti in 1986 and the Number of enrolments of both sexes in Puerto Rico in 1988?
Your response must be concise. -1.55e+05. What is the difference between the Number of enrolments of both sexes of Mauritania in 1986 and the Number of enrolments of both sexes of Puerto Rico in 1988?
Your response must be concise. -1.27e+05. What is the difference between the Number of enrolments of both sexes of Middle East & North Africa (developing only) in 1986 and the Number of enrolments of both sexes of Djibouti in 1989?
Offer a very short reply. 1.28e+07. What is the difference between the Number of enrolments of both sexes of Middle East & North Africa (developing only) in 1986 and the Number of enrolments of both sexes of Mauritania in 1989?
Keep it short and to the point. 1.28e+07. What is the difference between the Number of enrolments of both sexes in Middle East & North Africa (developing only) in 1986 and the Number of enrolments of both sexes in Puerto Rico in 1989?
Your response must be concise. 1.27e+07. What is the difference between the Number of enrolments of both sexes of Djibouti in 1986 and the Number of enrolments of both sexes of Mauritania in 1989?
Offer a very short reply. -3.23e+04. What is the difference between the Number of enrolments of both sexes of Djibouti in 1986 and the Number of enrolments of both sexes of Puerto Rico in 1989?
Give a very brief answer. -1.55e+05. What is the difference between the Number of enrolments of both sexes of Mauritania in 1986 and the Number of enrolments of both sexes of Puerto Rico in 1989?
Your response must be concise. -1.27e+05. What is the difference between the Number of enrolments of both sexes of Middle East & North Africa (developing only) in 1987 and the Number of enrolments of both sexes of Djibouti in 1988?
Your answer should be very brief. 1.35e+07. What is the difference between the Number of enrolments of both sexes in Middle East & North Africa (developing only) in 1987 and the Number of enrolments of both sexes in Mauritania in 1988?
Your response must be concise. 1.34e+07. What is the difference between the Number of enrolments of both sexes of Middle East & North Africa (developing only) in 1987 and the Number of enrolments of both sexes of Puerto Rico in 1988?
Provide a succinct answer. 1.33e+07. What is the difference between the Number of enrolments of both sexes of Djibouti in 1987 and the Number of enrolments of both sexes of Mauritania in 1988?
Provide a short and direct response. -3.19e+04. What is the difference between the Number of enrolments of both sexes of Djibouti in 1987 and the Number of enrolments of both sexes of Puerto Rico in 1988?
Your answer should be compact. -1.54e+05. What is the difference between the Number of enrolments of both sexes in Mauritania in 1987 and the Number of enrolments of both sexes in Puerto Rico in 1988?
Your answer should be compact. -1.25e+05. What is the difference between the Number of enrolments of both sexes of Middle East & North Africa (developing only) in 1987 and the Number of enrolments of both sexes of Djibouti in 1989?
Provide a succinct answer. 1.35e+07. What is the difference between the Number of enrolments of both sexes in Middle East & North Africa (developing only) in 1987 and the Number of enrolments of both sexes in Mauritania in 1989?
Your response must be concise. 1.34e+07. What is the difference between the Number of enrolments of both sexes of Middle East & North Africa (developing only) in 1987 and the Number of enrolments of both sexes of Puerto Rico in 1989?
Give a very brief answer. 1.33e+07. What is the difference between the Number of enrolments of both sexes in Djibouti in 1987 and the Number of enrolments of both sexes in Mauritania in 1989?
Your answer should be very brief. -3.18e+04. What is the difference between the Number of enrolments of both sexes of Djibouti in 1987 and the Number of enrolments of both sexes of Puerto Rico in 1989?
Your response must be concise. -1.54e+05. What is the difference between the Number of enrolments of both sexes in Mauritania in 1987 and the Number of enrolments of both sexes in Puerto Rico in 1989?
Provide a succinct answer. -1.25e+05. What is the difference between the Number of enrolments of both sexes in Middle East & North Africa (developing only) in 1988 and the Number of enrolments of both sexes in Djibouti in 1989?
Your response must be concise. 1.41e+07. What is the difference between the Number of enrolments of both sexes of Middle East & North Africa (developing only) in 1988 and the Number of enrolments of both sexes of Mauritania in 1989?
Your answer should be very brief. 1.40e+07. What is the difference between the Number of enrolments of both sexes in Middle East & North Africa (developing only) in 1988 and the Number of enrolments of both sexes in Puerto Rico in 1989?
Your answer should be compact. 1.39e+07. What is the difference between the Number of enrolments of both sexes in Djibouti in 1988 and the Number of enrolments of both sexes in Mauritania in 1989?
Keep it short and to the point. -3.16e+04. What is the difference between the Number of enrolments of both sexes in Djibouti in 1988 and the Number of enrolments of both sexes in Puerto Rico in 1989?
Your response must be concise. -1.54e+05. What is the difference between the Number of enrolments of both sexes in Mauritania in 1988 and the Number of enrolments of both sexes in Puerto Rico in 1989?
Provide a short and direct response. -1.23e+05. What is the average Number of enrolments of both sexes in Middle East & North Africa (developing only) per year?
Offer a very short reply. 1.24e+07. What is the average Number of enrolments of both sexes in Djibouti per year?
Your response must be concise. 5150.38. What is the average Number of enrolments of both sexes of Mauritania per year?
Your answer should be compact. 3.13e+04. What is the average Number of enrolments of both sexes in Puerto Rico per year?
Your answer should be very brief. 1.70e+05. In the year 1982, what is the difference between the Number of enrolments of both sexes in Middle East & North Africa (developing only) and Number of enrolments of both sexes in Djibouti?
Offer a terse response. 1.03e+07. In the year 1982, what is the difference between the Number of enrolments of both sexes in Middle East & North Africa (developing only) and Number of enrolments of both sexes in Mauritania?
Make the answer very short. 1.03e+07. In the year 1982, what is the difference between the Number of enrolments of both sexes of Middle East & North Africa (developing only) and Number of enrolments of both sexes of Puerto Rico?
Offer a very short reply. 1.01e+07. In the year 1982, what is the difference between the Number of enrolments of both sexes of Djibouti and Number of enrolments of both sexes of Mauritania?
Give a very brief answer. -1.88e+04. In the year 1982, what is the difference between the Number of enrolments of both sexes of Djibouti and Number of enrolments of both sexes of Puerto Rico?
Make the answer very short. -1.97e+05. In the year 1982, what is the difference between the Number of enrolments of both sexes of Mauritania and Number of enrolments of both sexes of Puerto Rico?
Provide a succinct answer. -1.78e+05. In the year 1983, what is the difference between the Number of enrolments of both sexes in Middle East & North Africa (developing only) and Number of enrolments of both sexes in Djibouti?
Provide a short and direct response. 1.08e+07. In the year 1983, what is the difference between the Number of enrolments of both sexes of Middle East & North Africa (developing only) and Number of enrolments of both sexes of Mauritania?
Provide a succinct answer. 1.08e+07. In the year 1983, what is the difference between the Number of enrolments of both sexes of Middle East & North Africa (developing only) and Number of enrolments of both sexes of Puerto Rico?
Your answer should be compact. 1.06e+07. In the year 1983, what is the difference between the Number of enrolments of both sexes of Djibouti and Number of enrolments of both sexes of Mauritania?
Your answer should be very brief. -2.13e+04. In the year 1983, what is the difference between the Number of enrolments of both sexes in Djibouti and Number of enrolments of both sexes in Puerto Rico?
Your response must be concise. -1.80e+05. In the year 1983, what is the difference between the Number of enrolments of both sexes of Mauritania and Number of enrolments of both sexes of Puerto Rico?
Offer a terse response. -1.58e+05. In the year 1984, what is the difference between the Number of enrolments of both sexes of Middle East & North Africa (developing only) and Number of enrolments of both sexes of Djibouti?
Give a very brief answer. 1.14e+07. In the year 1984, what is the difference between the Number of enrolments of both sexes of Middle East & North Africa (developing only) and Number of enrolments of both sexes of Mauritania?
Keep it short and to the point. 1.14e+07. In the year 1984, what is the difference between the Number of enrolments of both sexes of Middle East & North Africa (developing only) and Number of enrolments of both sexes of Puerto Rico?
Offer a terse response. 1.12e+07. In the year 1984, what is the difference between the Number of enrolments of both sexes in Djibouti and Number of enrolments of both sexes in Mauritania?
Offer a terse response. -2.31e+04. In the year 1984, what is the difference between the Number of enrolments of both sexes of Djibouti and Number of enrolments of both sexes of Puerto Rico?
Make the answer very short. -1.70e+05. In the year 1984, what is the difference between the Number of enrolments of both sexes of Mauritania and Number of enrolments of both sexes of Puerto Rico?
Ensure brevity in your answer.  -1.47e+05. In the year 1985, what is the difference between the Number of enrolments of both sexes of Middle East & North Africa (developing only) and Number of enrolments of both sexes of Djibouti?
Your answer should be very brief. 1.20e+07. In the year 1985, what is the difference between the Number of enrolments of both sexes in Middle East & North Africa (developing only) and Number of enrolments of both sexes in Mauritania?
Offer a terse response. 1.20e+07. In the year 1985, what is the difference between the Number of enrolments of both sexes of Middle East & North Africa (developing only) and Number of enrolments of both sexes of Puerto Rico?
Make the answer very short. 1.18e+07. In the year 1985, what is the difference between the Number of enrolments of both sexes in Djibouti and Number of enrolments of both sexes in Mauritania?
Your response must be concise. -2.59e+04. In the year 1985, what is the difference between the Number of enrolments of both sexes of Djibouti and Number of enrolments of both sexes of Puerto Rico?
Provide a succinct answer. -1.61e+05. In the year 1985, what is the difference between the Number of enrolments of both sexes of Mauritania and Number of enrolments of both sexes of Puerto Rico?
Offer a terse response. -1.35e+05. In the year 1986, what is the difference between the Number of enrolments of both sexes in Middle East & North Africa (developing only) and Number of enrolments of both sexes in Djibouti?
Give a very brief answer. 1.28e+07. In the year 1986, what is the difference between the Number of enrolments of both sexes in Middle East & North Africa (developing only) and Number of enrolments of both sexes in Mauritania?
Keep it short and to the point. 1.28e+07. In the year 1986, what is the difference between the Number of enrolments of both sexes of Middle East & North Africa (developing only) and Number of enrolments of both sexes of Puerto Rico?
Provide a short and direct response. 1.27e+07. In the year 1986, what is the difference between the Number of enrolments of both sexes of Djibouti and Number of enrolments of both sexes of Mauritania?
Your response must be concise. -2.81e+04. In the year 1986, what is the difference between the Number of enrolments of both sexes in Djibouti and Number of enrolments of both sexes in Puerto Rico?
Your response must be concise. -1.52e+05. In the year 1986, what is the difference between the Number of enrolments of both sexes in Mauritania and Number of enrolments of both sexes in Puerto Rico?
Your response must be concise. -1.24e+05. In the year 1987, what is the difference between the Number of enrolments of both sexes in Middle East & North Africa (developing only) and Number of enrolments of both sexes in Djibouti?
Your answer should be very brief. 1.35e+07. In the year 1987, what is the difference between the Number of enrolments of both sexes of Middle East & North Africa (developing only) and Number of enrolments of both sexes of Mauritania?
Offer a very short reply. 1.34e+07. In the year 1987, what is the difference between the Number of enrolments of both sexes of Middle East & North Africa (developing only) and Number of enrolments of both sexes of Puerto Rico?
Offer a terse response. 1.33e+07. In the year 1987, what is the difference between the Number of enrolments of both sexes in Djibouti and Number of enrolments of both sexes in Mauritania?
Your response must be concise. -2.96e+04. In the year 1987, what is the difference between the Number of enrolments of both sexes in Djibouti and Number of enrolments of both sexes in Puerto Rico?
Your answer should be very brief. -1.54e+05. In the year 1987, what is the difference between the Number of enrolments of both sexes in Mauritania and Number of enrolments of both sexes in Puerto Rico?
Provide a short and direct response. -1.25e+05. In the year 1988, what is the difference between the Number of enrolments of both sexes of Middle East & North Africa (developing only) and Number of enrolments of both sexes of Djibouti?
Ensure brevity in your answer.  1.41e+07. In the year 1988, what is the difference between the Number of enrolments of both sexes of Middle East & North Africa (developing only) and Number of enrolments of both sexes of Mauritania?
Ensure brevity in your answer.  1.40e+07. In the year 1988, what is the difference between the Number of enrolments of both sexes in Middle East & North Africa (developing only) and Number of enrolments of both sexes in Puerto Rico?
Ensure brevity in your answer.  1.39e+07. In the year 1988, what is the difference between the Number of enrolments of both sexes in Djibouti and Number of enrolments of both sexes in Mauritania?
Make the answer very short. -3.16e+04. In the year 1988, what is the difference between the Number of enrolments of both sexes of Djibouti and Number of enrolments of both sexes of Puerto Rico?
Your answer should be compact. -1.54e+05. In the year 1988, what is the difference between the Number of enrolments of both sexes of Mauritania and Number of enrolments of both sexes of Puerto Rico?
Provide a short and direct response. -1.23e+05. In the year 1989, what is the difference between the Number of enrolments of both sexes in Middle East & North Africa (developing only) and Number of enrolments of both sexes in Djibouti?
Provide a succinct answer. 1.46e+07. In the year 1989, what is the difference between the Number of enrolments of both sexes in Middle East & North Africa (developing only) and Number of enrolments of both sexes in Mauritania?
Ensure brevity in your answer.  1.46e+07. In the year 1989, what is the difference between the Number of enrolments of both sexes in Middle East & North Africa (developing only) and Number of enrolments of both sexes in Puerto Rico?
Give a very brief answer. 1.45e+07. In the year 1989, what is the difference between the Number of enrolments of both sexes in Djibouti and Number of enrolments of both sexes in Mauritania?
Offer a terse response. -3.08e+04. In the year 1989, what is the difference between the Number of enrolments of both sexes of Djibouti and Number of enrolments of both sexes of Puerto Rico?
Provide a succinct answer. -1.53e+05. In the year 1989, what is the difference between the Number of enrolments of both sexes of Mauritania and Number of enrolments of both sexes of Puerto Rico?
Provide a succinct answer. -1.23e+05. What is the ratio of the Number of enrolments of both sexes in Middle East & North Africa (developing only) in 1982 to that in 1983?
Offer a very short reply. 0.96. What is the ratio of the Number of enrolments of both sexes in Djibouti in 1982 to that in 1983?
Offer a very short reply. 0.92. What is the ratio of the Number of enrolments of both sexes of Mauritania in 1982 to that in 1983?
Offer a terse response. 0.89. What is the ratio of the Number of enrolments of both sexes in Puerto Rico in 1982 to that in 1983?
Give a very brief answer. 1.09. What is the ratio of the Number of enrolments of both sexes in Middle East & North Africa (developing only) in 1982 to that in 1984?
Provide a short and direct response. 0.91. What is the ratio of the Number of enrolments of both sexes in Djibouti in 1982 to that in 1984?
Offer a terse response. 0.85. What is the ratio of the Number of enrolments of both sexes of Mauritania in 1982 to that in 1984?
Provide a short and direct response. 0.82. What is the ratio of the Number of enrolments of both sexes in Puerto Rico in 1982 to that in 1984?
Make the answer very short. 1.15. What is the ratio of the Number of enrolments of both sexes in Middle East & North Africa (developing only) in 1982 to that in 1985?
Your answer should be very brief. 0.86. What is the ratio of the Number of enrolments of both sexes in Djibouti in 1982 to that in 1985?
Ensure brevity in your answer.  0.82. What is the ratio of the Number of enrolments of both sexes of Mauritania in 1982 to that in 1985?
Your answer should be compact. 0.74. What is the ratio of the Number of enrolments of both sexes in Puerto Rico in 1982 to that in 1985?
Offer a very short reply. 1.21. What is the ratio of the Number of enrolments of both sexes in Middle East & North Africa (developing only) in 1982 to that in 1986?
Ensure brevity in your answer.  0.81. What is the ratio of the Number of enrolments of both sexes of Djibouti in 1982 to that in 1986?
Your answer should be compact. 0.81. What is the ratio of the Number of enrolments of both sexes in Mauritania in 1982 to that in 1986?
Your response must be concise. 0.69. What is the ratio of the Number of enrolments of both sexes in Puerto Rico in 1982 to that in 1986?
Give a very brief answer. 1.28. What is the ratio of the Number of enrolments of both sexes in Middle East & North Africa (developing only) in 1982 to that in 1987?
Your response must be concise. 0.77. What is the ratio of the Number of enrolments of both sexes of Djibouti in 1982 to that in 1987?
Your answer should be compact. 0.74. What is the ratio of the Number of enrolments of both sexes of Mauritania in 1982 to that in 1987?
Your answer should be very brief. 0.65. What is the ratio of the Number of enrolments of both sexes of Puerto Rico in 1982 to that in 1987?
Make the answer very short. 1.26. What is the ratio of the Number of enrolments of both sexes in Middle East & North Africa (developing only) in 1982 to that in 1988?
Your answer should be very brief. 0.73. What is the ratio of the Number of enrolments of both sexes in Djibouti in 1982 to that in 1988?
Offer a terse response. 0.7. What is the ratio of the Number of enrolments of both sexes of Mauritania in 1982 to that in 1988?
Give a very brief answer. 0.61. What is the ratio of the Number of enrolments of both sexes of Puerto Rico in 1982 to that in 1988?
Provide a short and direct response. 1.26. What is the ratio of the Number of enrolments of both sexes of Middle East & North Africa (developing only) in 1982 to that in 1989?
Provide a short and direct response. 0.71. What is the ratio of the Number of enrolments of both sexes in Djibouti in 1982 to that in 1989?
Your answer should be compact. 0.62. What is the ratio of the Number of enrolments of both sexes of Mauritania in 1982 to that in 1989?
Keep it short and to the point. 0.61. What is the ratio of the Number of enrolments of both sexes in Puerto Rico in 1982 to that in 1989?
Keep it short and to the point. 1.26. What is the ratio of the Number of enrolments of both sexes in Middle East & North Africa (developing only) in 1983 to that in 1984?
Your answer should be compact. 0.95. What is the ratio of the Number of enrolments of both sexes of Djibouti in 1983 to that in 1984?
Your response must be concise. 0.92. What is the ratio of the Number of enrolments of both sexes of Mauritania in 1983 to that in 1984?
Your answer should be very brief. 0.92. What is the ratio of the Number of enrolments of both sexes of Puerto Rico in 1983 to that in 1984?
Provide a short and direct response. 1.05. What is the ratio of the Number of enrolments of both sexes of Middle East & North Africa (developing only) in 1983 to that in 1985?
Give a very brief answer. 0.9. What is the ratio of the Number of enrolments of both sexes in Djibouti in 1983 to that in 1985?
Your answer should be very brief. 0.89. What is the ratio of the Number of enrolments of both sexes in Mauritania in 1983 to that in 1985?
Make the answer very short. 0.83. What is the ratio of the Number of enrolments of both sexes of Puerto Rico in 1983 to that in 1985?
Offer a terse response. 1.11. What is the ratio of the Number of enrolments of both sexes in Middle East & North Africa (developing only) in 1983 to that in 1986?
Your answer should be compact. 0.84. What is the ratio of the Number of enrolments of both sexes of Djibouti in 1983 to that in 1986?
Offer a very short reply. 0.88. What is the ratio of the Number of enrolments of both sexes in Mauritania in 1983 to that in 1986?
Your response must be concise. 0.78. What is the ratio of the Number of enrolments of both sexes in Puerto Rico in 1983 to that in 1986?
Provide a short and direct response. 1.17. What is the ratio of the Number of enrolments of both sexes in Middle East & North Africa (developing only) in 1983 to that in 1987?
Provide a succinct answer. 0.8. What is the ratio of the Number of enrolments of both sexes of Djibouti in 1983 to that in 1987?
Offer a terse response. 0.8. What is the ratio of the Number of enrolments of both sexes of Mauritania in 1983 to that in 1987?
Make the answer very short. 0.73. What is the ratio of the Number of enrolments of both sexes of Puerto Rico in 1983 to that in 1987?
Provide a short and direct response. 1.15. What is the ratio of the Number of enrolments of both sexes in Middle East & North Africa (developing only) in 1983 to that in 1988?
Keep it short and to the point. 0.77. What is the ratio of the Number of enrolments of both sexes of Djibouti in 1983 to that in 1988?
Offer a very short reply. 0.76. What is the ratio of the Number of enrolments of both sexes of Mauritania in 1983 to that in 1988?
Your answer should be very brief. 0.69. What is the ratio of the Number of enrolments of both sexes in Puerto Rico in 1983 to that in 1988?
Offer a very short reply. 1.15. What is the ratio of the Number of enrolments of both sexes in Middle East & North Africa (developing only) in 1983 to that in 1989?
Keep it short and to the point. 0.74. What is the ratio of the Number of enrolments of both sexes of Djibouti in 1983 to that in 1989?
Provide a short and direct response. 0.68. What is the ratio of the Number of enrolments of both sexes in Mauritania in 1983 to that in 1989?
Make the answer very short. 0.69. What is the ratio of the Number of enrolments of both sexes in Puerto Rico in 1983 to that in 1989?
Keep it short and to the point. 1.15. What is the ratio of the Number of enrolments of both sexes in Middle East & North Africa (developing only) in 1984 to that in 1985?
Your response must be concise. 0.95. What is the ratio of the Number of enrolments of both sexes in Djibouti in 1984 to that in 1985?
Give a very brief answer. 0.96. What is the ratio of the Number of enrolments of both sexes of Mauritania in 1984 to that in 1985?
Provide a short and direct response. 0.91. What is the ratio of the Number of enrolments of both sexes in Puerto Rico in 1984 to that in 1985?
Give a very brief answer. 1.05. What is the ratio of the Number of enrolments of both sexes of Middle East & North Africa (developing only) in 1984 to that in 1986?
Ensure brevity in your answer.  0.89. What is the ratio of the Number of enrolments of both sexes of Mauritania in 1984 to that in 1986?
Your answer should be very brief. 0.84. What is the ratio of the Number of enrolments of both sexes of Puerto Rico in 1984 to that in 1986?
Offer a terse response. 1.11. What is the ratio of the Number of enrolments of both sexes in Middle East & North Africa (developing only) in 1984 to that in 1987?
Ensure brevity in your answer.  0.85. What is the ratio of the Number of enrolments of both sexes in Djibouti in 1984 to that in 1987?
Give a very brief answer. 0.87. What is the ratio of the Number of enrolments of both sexes of Mauritania in 1984 to that in 1987?
Provide a short and direct response. 0.79. What is the ratio of the Number of enrolments of both sexes of Puerto Rico in 1984 to that in 1987?
Your answer should be very brief. 1.09. What is the ratio of the Number of enrolments of both sexes in Middle East & North Africa (developing only) in 1984 to that in 1988?
Your answer should be compact. 0.81. What is the ratio of the Number of enrolments of both sexes in Djibouti in 1984 to that in 1988?
Make the answer very short. 0.83. What is the ratio of the Number of enrolments of both sexes of Mauritania in 1984 to that in 1988?
Ensure brevity in your answer.  0.75. What is the ratio of the Number of enrolments of both sexes of Puerto Rico in 1984 to that in 1988?
Provide a succinct answer. 1.09. What is the ratio of the Number of enrolments of both sexes of Middle East & North Africa (developing only) in 1984 to that in 1989?
Offer a very short reply. 0.78. What is the ratio of the Number of enrolments of both sexes of Djibouti in 1984 to that in 1989?
Ensure brevity in your answer.  0.73. What is the ratio of the Number of enrolments of both sexes in Mauritania in 1984 to that in 1989?
Keep it short and to the point. 0.75. What is the ratio of the Number of enrolments of both sexes in Puerto Rico in 1984 to that in 1989?
Your answer should be very brief. 1.09. What is the ratio of the Number of enrolments of both sexes of Middle East & North Africa (developing only) in 1985 to that in 1986?
Give a very brief answer. 0.94. What is the ratio of the Number of enrolments of both sexes of Djibouti in 1985 to that in 1986?
Offer a terse response. 0.98. What is the ratio of the Number of enrolments of both sexes of Mauritania in 1985 to that in 1986?
Offer a terse response. 0.93. What is the ratio of the Number of enrolments of both sexes of Puerto Rico in 1985 to that in 1986?
Offer a terse response. 1.05. What is the ratio of the Number of enrolments of both sexes in Middle East & North Africa (developing only) in 1985 to that in 1987?
Give a very brief answer. 0.89. What is the ratio of the Number of enrolments of both sexes of Djibouti in 1985 to that in 1987?
Keep it short and to the point. 0.9. What is the ratio of the Number of enrolments of both sexes of Mauritania in 1985 to that in 1987?
Your response must be concise. 0.88. What is the ratio of the Number of enrolments of both sexes of Puerto Rico in 1985 to that in 1987?
Make the answer very short. 1.04. What is the ratio of the Number of enrolments of both sexes of Middle East & North Africa (developing only) in 1985 to that in 1988?
Your response must be concise. 0.85. What is the ratio of the Number of enrolments of both sexes of Djibouti in 1985 to that in 1988?
Your response must be concise. 0.86. What is the ratio of the Number of enrolments of both sexes of Mauritania in 1985 to that in 1988?
Keep it short and to the point. 0.82. What is the ratio of the Number of enrolments of both sexes in Puerto Rico in 1985 to that in 1988?
Your answer should be compact. 1.04. What is the ratio of the Number of enrolments of both sexes of Middle East & North Africa (developing only) in 1985 to that in 1989?
Give a very brief answer. 0.82. What is the ratio of the Number of enrolments of both sexes in Djibouti in 1985 to that in 1989?
Provide a succinct answer. 0.76. What is the ratio of the Number of enrolments of both sexes in Mauritania in 1985 to that in 1989?
Provide a succinct answer. 0.83. What is the ratio of the Number of enrolments of both sexes in Puerto Rico in 1985 to that in 1989?
Your answer should be compact. 1.04. What is the ratio of the Number of enrolments of both sexes of Middle East & North Africa (developing only) in 1986 to that in 1987?
Make the answer very short. 0.95. What is the ratio of the Number of enrolments of both sexes of Djibouti in 1986 to that in 1987?
Give a very brief answer. 0.91. What is the ratio of the Number of enrolments of both sexes in Mauritania in 1986 to that in 1987?
Provide a short and direct response. 0.94. What is the ratio of the Number of enrolments of both sexes in Puerto Rico in 1986 to that in 1987?
Offer a terse response. 0.98. What is the ratio of the Number of enrolments of both sexes of Middle East & North Africa (developing only) in 1986 to that in 1988?
Your answer should be compact. 0.91. What is the ratio of the Number of enrolments of both sexes of Djibouti in 1986 to that in 1988?
Your response must be concise. 0.87. What is the ratio of the Number of enrolments of both sexes of Mauritania in 1986 to that in 1988?
Give a very brief answer. 0.89. What is the ratio of the Number of enrolments of both sexes in Puerto Rico in 1986 to that in 1988?
Provide a succinct answer. 0.98. What is the ratio of the Number of enrolments of both sexes of Middle East & North Africa (developing only) in 1986 to that in 1989?
Keep it short and to the point. 0.88. What is the ratio of the Number of enrolments of both sexes of Djibouti in 1986 to that in 1989?
Offer a very short reply. 0.77. What is the ratio of the Number of enrolments of both sexes in Mauritania in 1986 to that in 1989?
Your answer should be compact. 0.89. What is the ratio of the Number of enrolments of both sexes of Puerto Rico in 1986 to that in 1989?
Keep it short and to the point. 0.98. What is the ratio of the Number of enrolments of both sexes in Middle East & North Africa (developing only) in 1987 to that in 1988?
Provide a succinct answer. 0.96. What is the ratio of the Number of enrolments of both sexes of Djibouti in 1987 to that in 1988?
Ensure brevity in your answer.  0.95. What is the ratio of the Number of enrolments of both sexes of Mauritania in 1987 to that in 1988?
Your response must be concise. 0.94. What is the ratio of the Number of enrolments of both sexes of Middle East & North Africa (developing only) in 1987 to that in 1989?
Provide a short and direct response. 0.92. What is the ratio of the Number of enrolments of both sexes in Djibouti in 1987 to that in 1989?
Your response must be concise. 0.85. What is the ratio of the Number of enrolments of both sexes in Puerto Rico in 1987 to that in 1989?
Offer a very short reply. 1. What is the ratio of the Number of enrolments of both sexes of Middle East & North Africa (developing only) in 1988 to that in 1989?
Ensure brevity in your answer.  0.96. What is the ratio of the Number of enrolments of both sexes in Djibouti in 1988 to that in 1989?
Your answer should be very brief. 0.89. What is the ratio of the Number of enrolments of both sexes in Puerto Rico in 1988 to that in 1989?
Offer a very short reply. 1. What is the difference between the highest and the second highest Number of enrolments of both sexes of Middle East & North Africa (developing only)?
Offer a terse response. 5.70e+05. What is the difference between the highest and the second highest Number of enrolments of both sexes in Djibouti?
Your answer should be very brief. 737. What is the difference between the highest and the second highest Number of enrolments of both sexes of Mauritania?
Give a very brief answer. 42. What is the difference between the highest and the second highest Number of enrolments of both sexes in Puerto Rico?
Your response must be concise. 1.69e+04. What is the difference between the highest and the lowest Number of enrolments of both sexes of Middle East & North Africa (developing only)?
Your answer should be very brief. 4.30e+06. What is the difference between the highest and the lowest Number of enrolments of both sexes of Djibouti?
Your answer should be compact. 2460. What is the difference between the highest and the lowest Number of enrolments of both sexes of Mauritania?
Provide a short and direct response. 1.46e+04. What is the difference between the highest and the lowest Number of enrolments of both sexes of Puerto Rico?
Ensure brevity in your answer.  4.36e+04. 